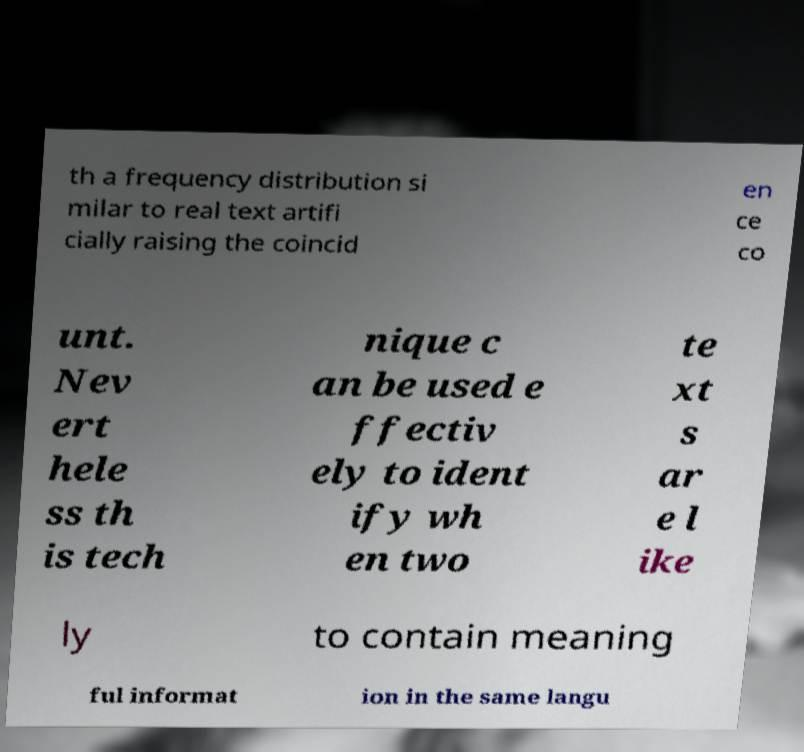Could you assist in decoding the text presented in this image and type it out clearly? th a frequency distribution si milar to real text artifi cially raising the coincid en ce co unt. Nev ert hele ss th is tech nique c an be used e ffectiv ely to ident ify wh en two te xt s ar e l ike ly to contain meaning ful informat ion in the same langu 